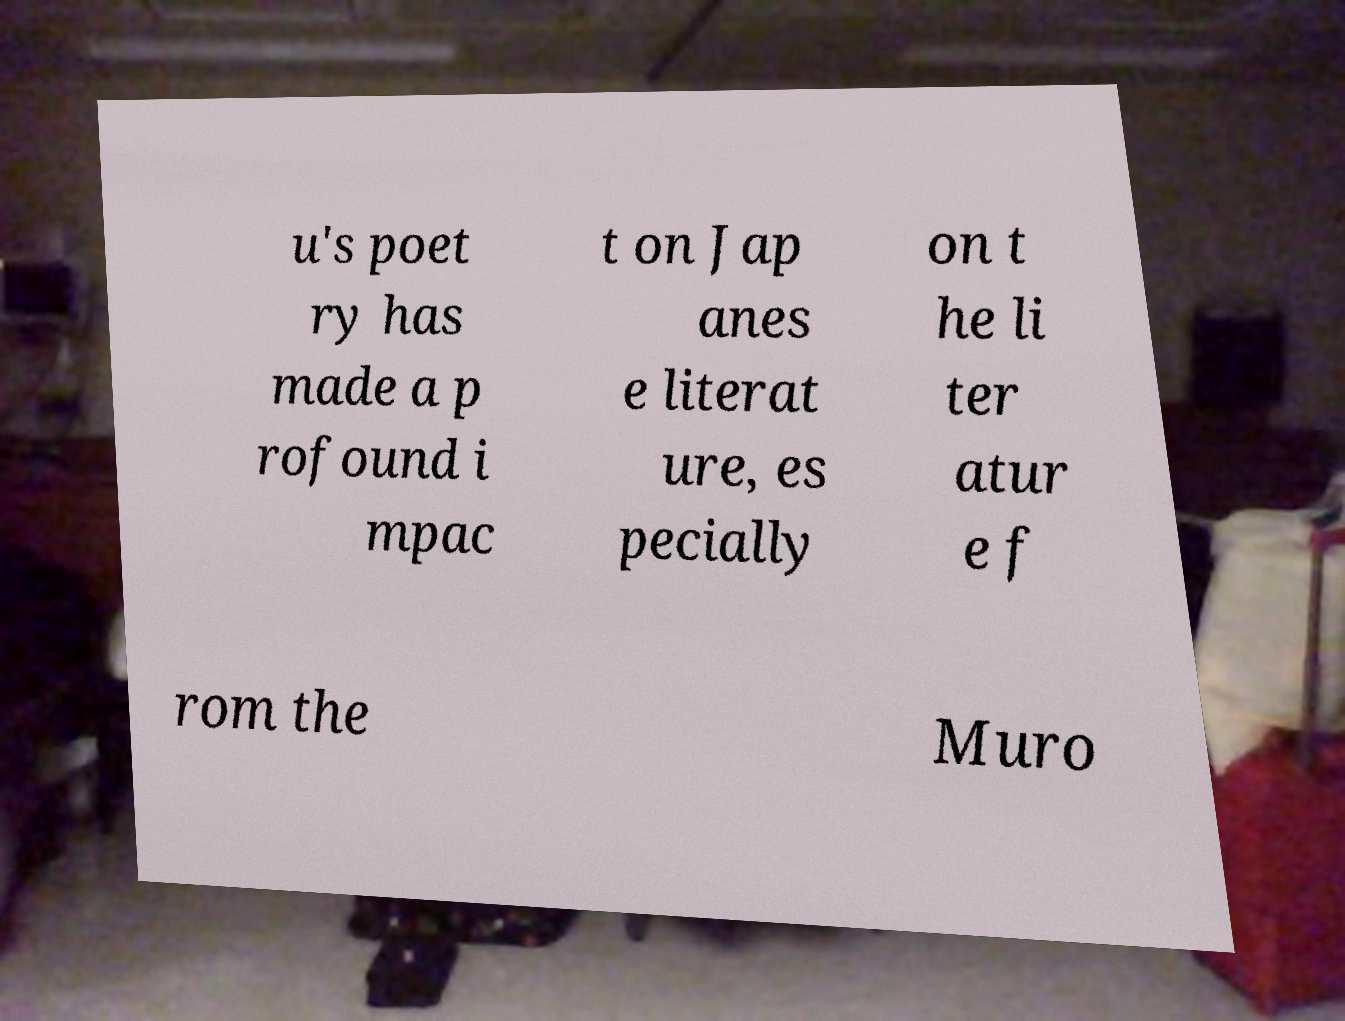What messages or text are displayed in this image? I need them in a readable, typed format. u's poet ry has made a p rofound i mpac t on Jap anes e literat ure, es pecially on t he li ter atur e f rom the Muro 